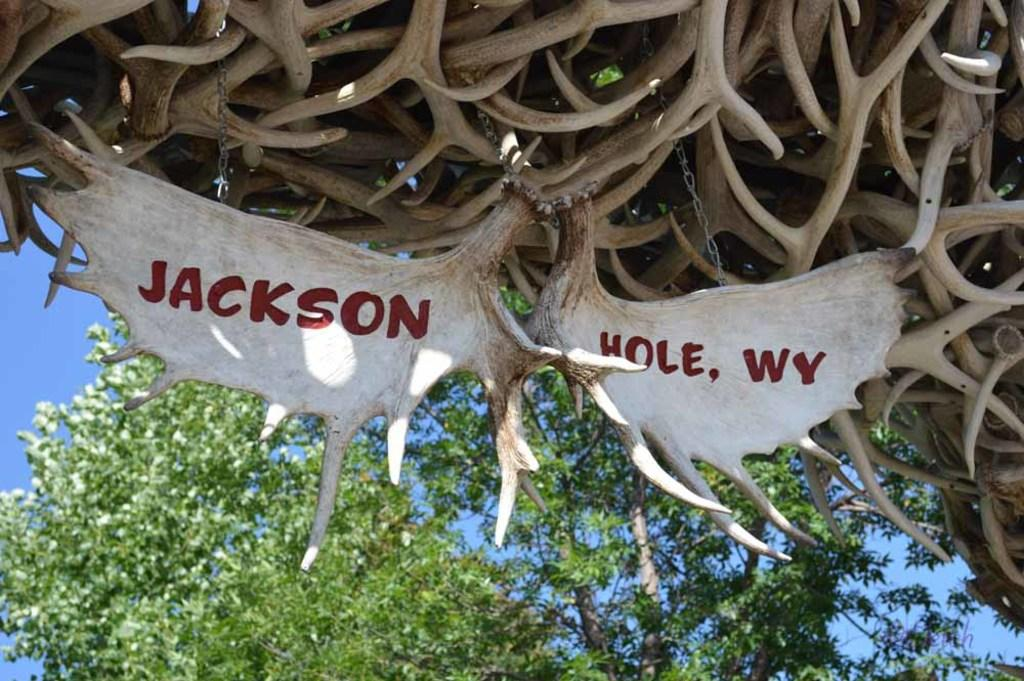What type of natural scenery can be seen in the background of the image? There are trees in the background of the image. What part of the natural environment is visible in the image? The sky is visible in the image. What type of structures are at the top of the image? There are wooden structures at the top of the image. What can be found on the wooden structures? Names are written on the wooden structures. How many spiders are crawling on the trees in the image? There are no spiders visible in the image; it only shows trees and the sky. 